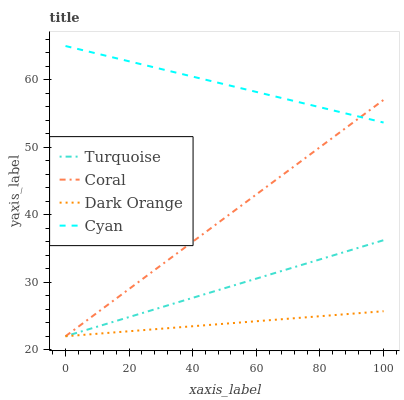Does Dark Orange have the minimum area under the curve?
Answer yes or no. Yes. Does Cyan have the maximum area under the curve?
Answer yes or no. Yes. Does Turquoise have the minimum area under the curve?
Answer yes or no. No. Does Turquoise have the maximum area under the curve?
Answer yes or no. No. Is Coral the smoothest?
Answer yes or no. Yes. Is Cyan the roughest?
Answer yes or no. Yes. Is Turquoise the smoothest?
Answer yes or no. No. Is Turquoise the roughest?
Answer yes or no. No. Does Dark Orange have the lowest value?
Answer yes or no. Yes. Does Cyan have the lowest value?
Answer yes or no. No. Does Cyan have the highest value?
Answer yes or no. Yes. Does Turquoise have the highest value?
Answer yes or no. No. Is Turquoise less than Cyan?
Answer yes or no. Yes. Is Cyan greater than Turquoise?
Answer yes or no. Yes. Does Cyan intersect Coral?
Answer yes or no. Yes. Is Cyan less than Coral?
Answer yes or no. No. Is Cyan greater than Coral?
Answer yes or no. No. Does Turquoise intersect Cyan?
Answer yes or no. No. 